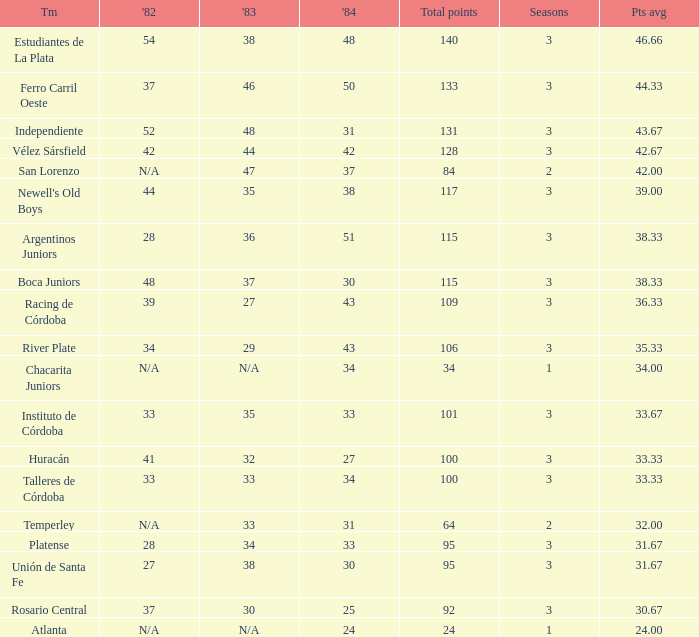What is the total for 1984 for the team with 100 points total and more than 3 seasons? None. 